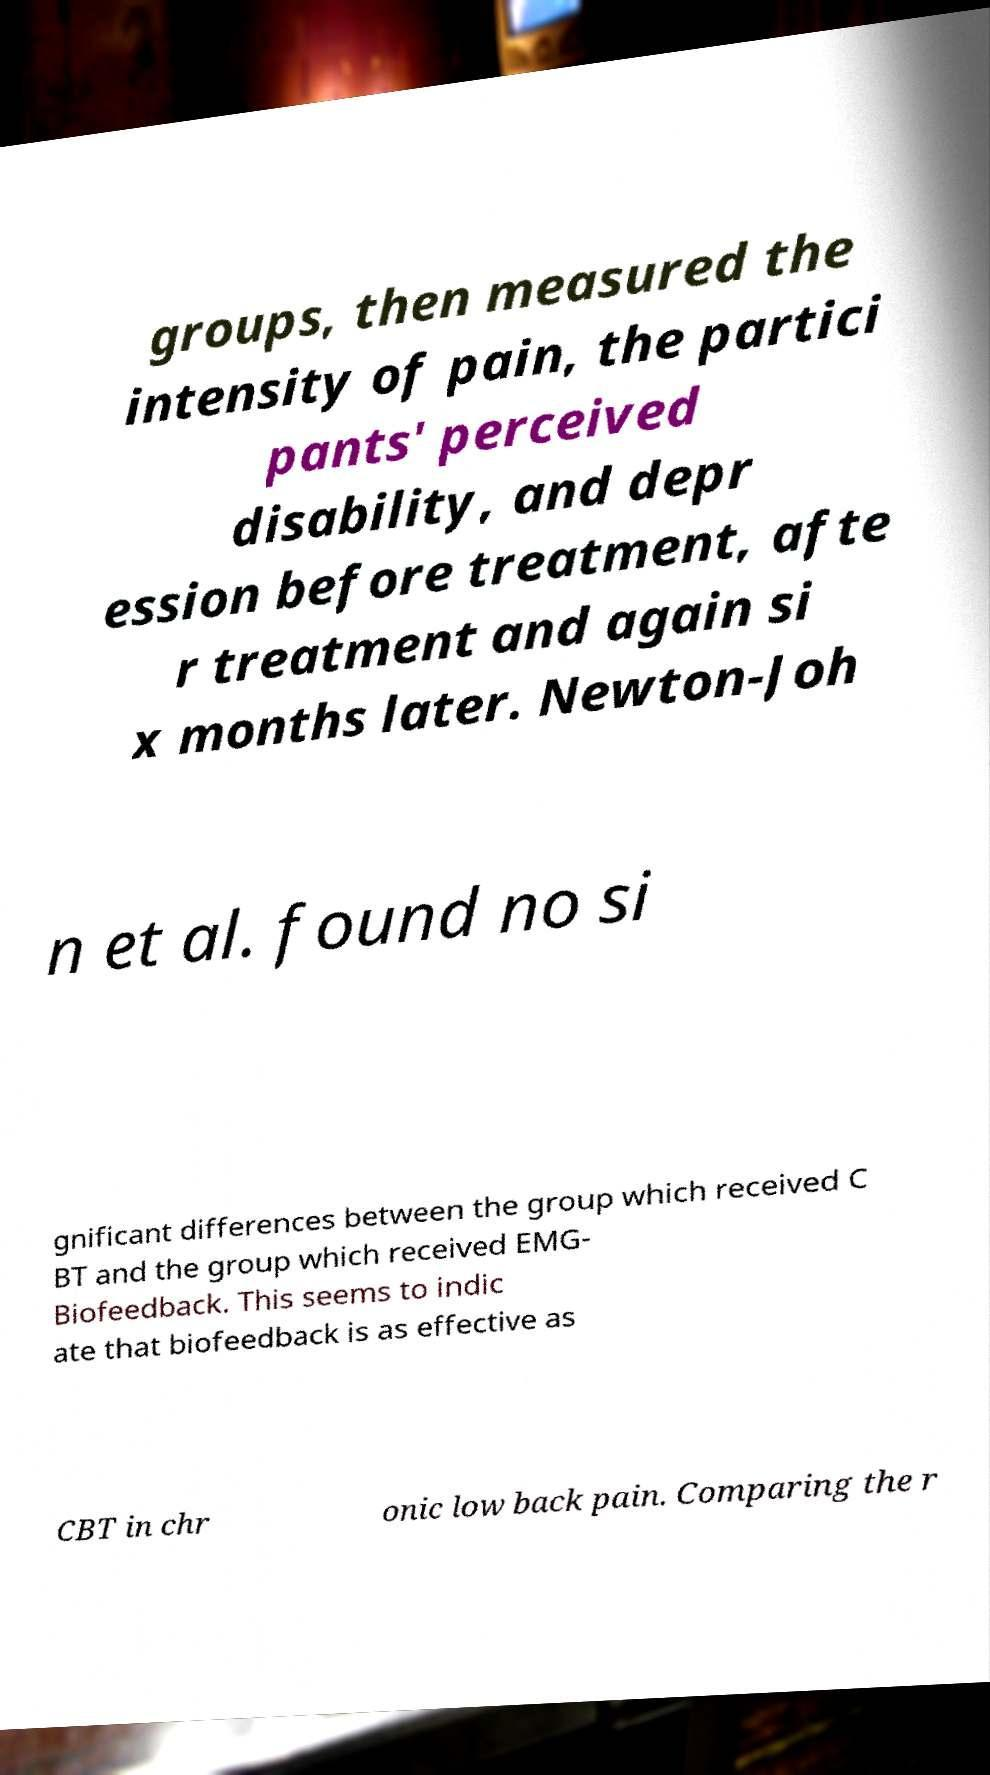For documentation purposes, I need the text within this image transcribed. Could you provide that? groups, then measured the intensity of pain, the partici pants' perceived disability, and depr ession before treatment, afte r treatment and again si x months later. Newton-Joh n et al. found no si gnificant differences between the group which received C BT and the group which received EMG- Biofeedback. This seems to indic ate that biofeedback is as effective as CBT in chr onic low back pain. Comparing the r 